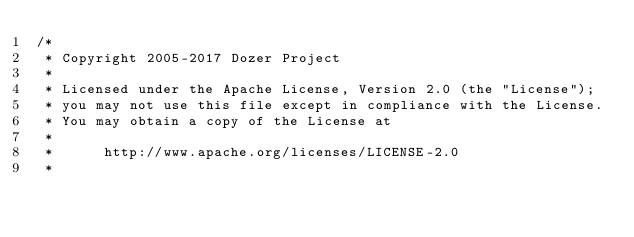Convert code to text. <code><loc_0><loc_0><loc_500><loc_500><_Java_>/*
 * Copyright 2005-2017 Dozer Project
 *
 * Licensed under the Apache License, Version 2.0 (the "License");
 * you may not use this file except in compliance with the License.
 * You may obtain a copy of the License at
 *
 *      http://www.apache.org/licenses/LICENSE-2.0
 *</code> 